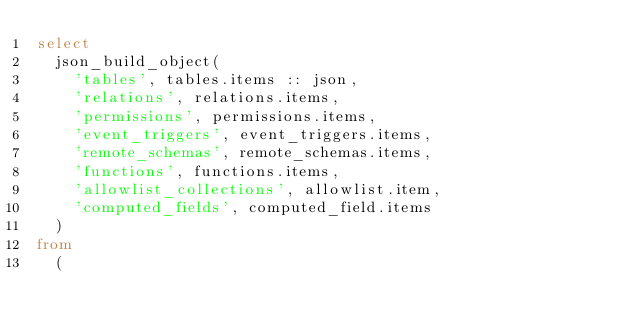Convert code to text. <code><loc_0><loc_0><loc_500><loc_500><_SQL_>select
  json_build_object(
    'tables', tables.items :: json,
    'relations', relations.items,
    'permissions', permissions.items,
    'event_triggers', event_triggers.items,
    'remote_schemas', remote_schemas.items,
    'functions', functions.items,
    'allowlist_collections', allowlist.item,
    'computed_fields', computed_field.items
  )
from
  (</code> 